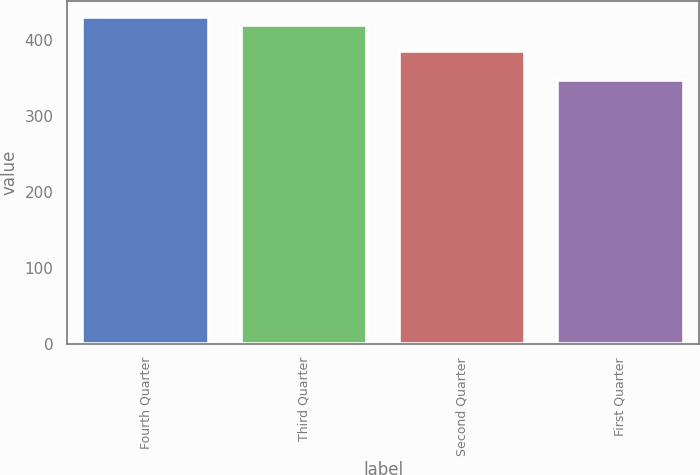Convert chart. <chart><loc_0><loc_0><loc_500><loc_500><bar_chart><fcel>Fourth Quarter<fcel>Third Quarter<fcel>Second Quarter<fcel>First Quarter<nl><fcel>429.91<fcel>419.83<fcel>385.5<fcel>347.09<nl></chart> 